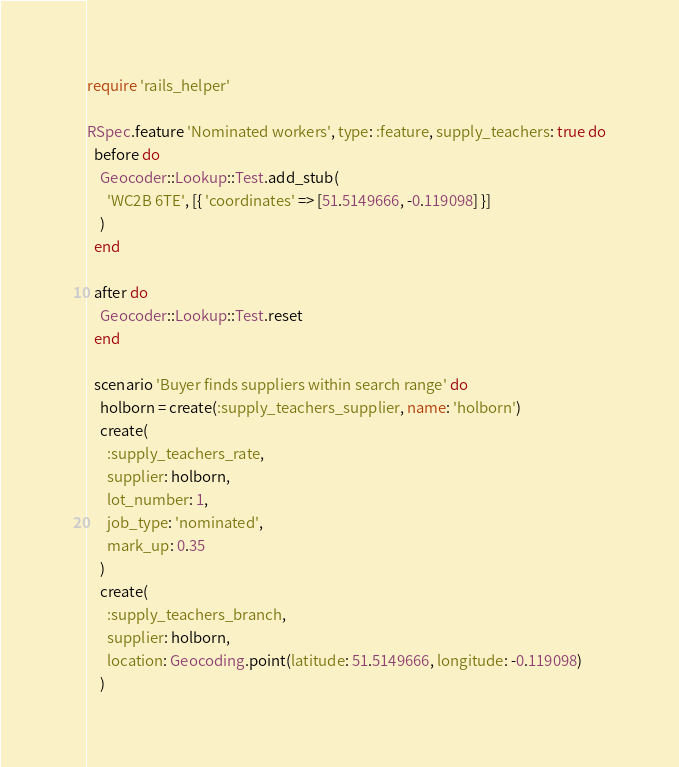<code> <loc_0><loc_0><loc_500><loc_500><_Ruby_>require 'rails_helper'

RSpec.feature 'Nominated workers', type: :feature, supply_teachers: true do
  before do
    Geocoder::Lookup::Test.add_stub(
      'WC2B 6TE', [{ 'coordinates' => [51.5149666, -0.119098] }]
    )
  end

  after do
    Geocoder::Lookup::Test.reset
  end

  scenario 'Buyer finds suppliers within search range' do
    holborn = create(:supply_teachers_supplier, name: 'holborn')
    create(
      :supply_teachers_rate,
      supplier: holborn,
      lot_number: 1,
      job_type: 'nominated',
      mark_up: 0.35
    )
    create(
      :supply_teachers_branch,
      supplier: holborn,
      location: Geocoding.point(latitude: 51.5149666, longitude: -0.119098)
    )</code> 